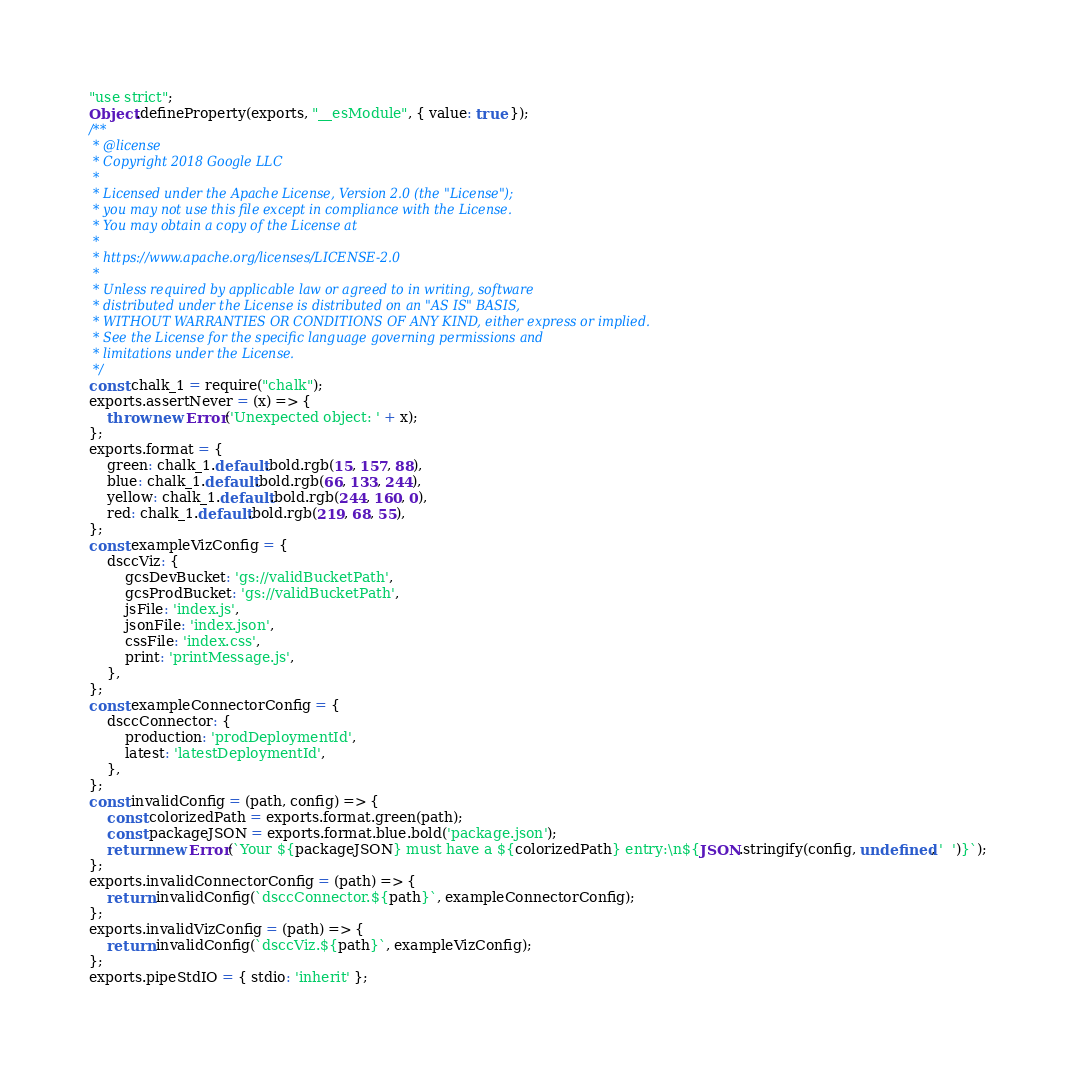<code> <loc_0><loc_0><loc_500><loc_500><_JavaScript_>"use strict";
Object.defineProperty(exports, "__esModule", { value: true });
/**
 * @license
 * Copyright 2018 Google LLC
 *
 * Licensed under the Apache License, Version 2.0 (the "License");
 * you may not use this file except in compliance with the License.
 * You may obtain a copy of the License at
 *
 * https://www.apache.org/licenses/LICENSE-2.0
 *
 * Unless required by applicable law or agreed to in writing, software
 * distributed under the License is distributed on an "AS IS" BASIS,
 * WITHOUT WARRANTIES OR CONDITIONS OF ANY KIND, either express or implied.
 * See the License for the specific language governing permissions and
 * limitations under the License.
 */
const chalk_1 = require("chalk");
exports.assertNever = (x) => {
    throw new Error('Unexpected object: ' + x);
};
exports.format = {
    green: chalk_1.default.bold.rgb(15, 157, 88),
    blue: chalk_1.default.bold.rgb(66, 133, 244),
    yellow: chalk_1.default.bold.rgb(244, 160, 0),
    red: chalk_1.default.bold.rgb(219, 68, 55),
};
const exampleVizConfig = {
    dsccViz: {
        gcsDevBucket: 'gs://validBucketPath',
        gcsProdBucket: 'gs://validBucketPath',
        jsFile: 'index.js',
        jsonFile: 'index.json',
        cssFile: 'index.css',
        print: 'printMessage.js',
    },
};
const exampleConnectorConfig = {
    dsccConnector: {
        production: 'prodDeploymentId',
        latest: 'latestDeploymentId',
    },
};
const invalidConfig = (path, config) => {
    const colorizedPath = exports.format.green(path);
    const packageJSON = exports.format.blue.bold('package.json');
    return new Error(`Your ${packageJSON} must have a ${colorizedPath} entry:\n${JSON.stringify(config, undefined, '  ')}`);
};
exports.invalidConnectorConfig = (path) => {
    return invalidConfig(`dsccConnector.${path}`, exampleConnectorConfig);
};
exports.invalidVizConfig = (path) => {
    return invalidConfig(`dsccViz.${path}`, exampleVizConfig);
};
exports.pipeStdIO = { stdio: 'inherit' };
</code> 